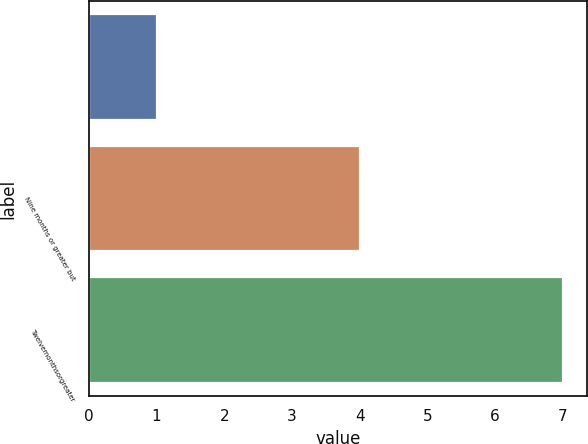Convert chart. <chart><loc_0><loc_0><loc_500><loc_500><bar_chart><ecel><fcel>Nine months or greater but<fcel>Twelvemonthsorgreater<nl><fcel>1<fcel>4<fcel>7<nl></chart> 